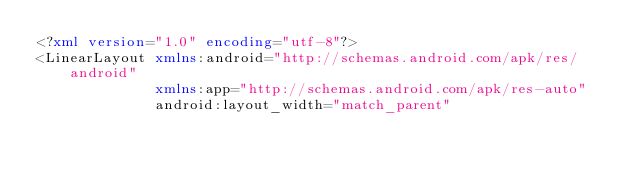<code> <loc_0><loc_0><loc_500><loc_500><_XML_><?xml version="1.0" encoding="utf-8"?>
<LinearLayout xmlns:android="http://schemas.android.com/apk/res/android"
              xmlns:app="http://schemas.android.com/apk/res-auto"
              android:layout_width="match_parent"</code> 